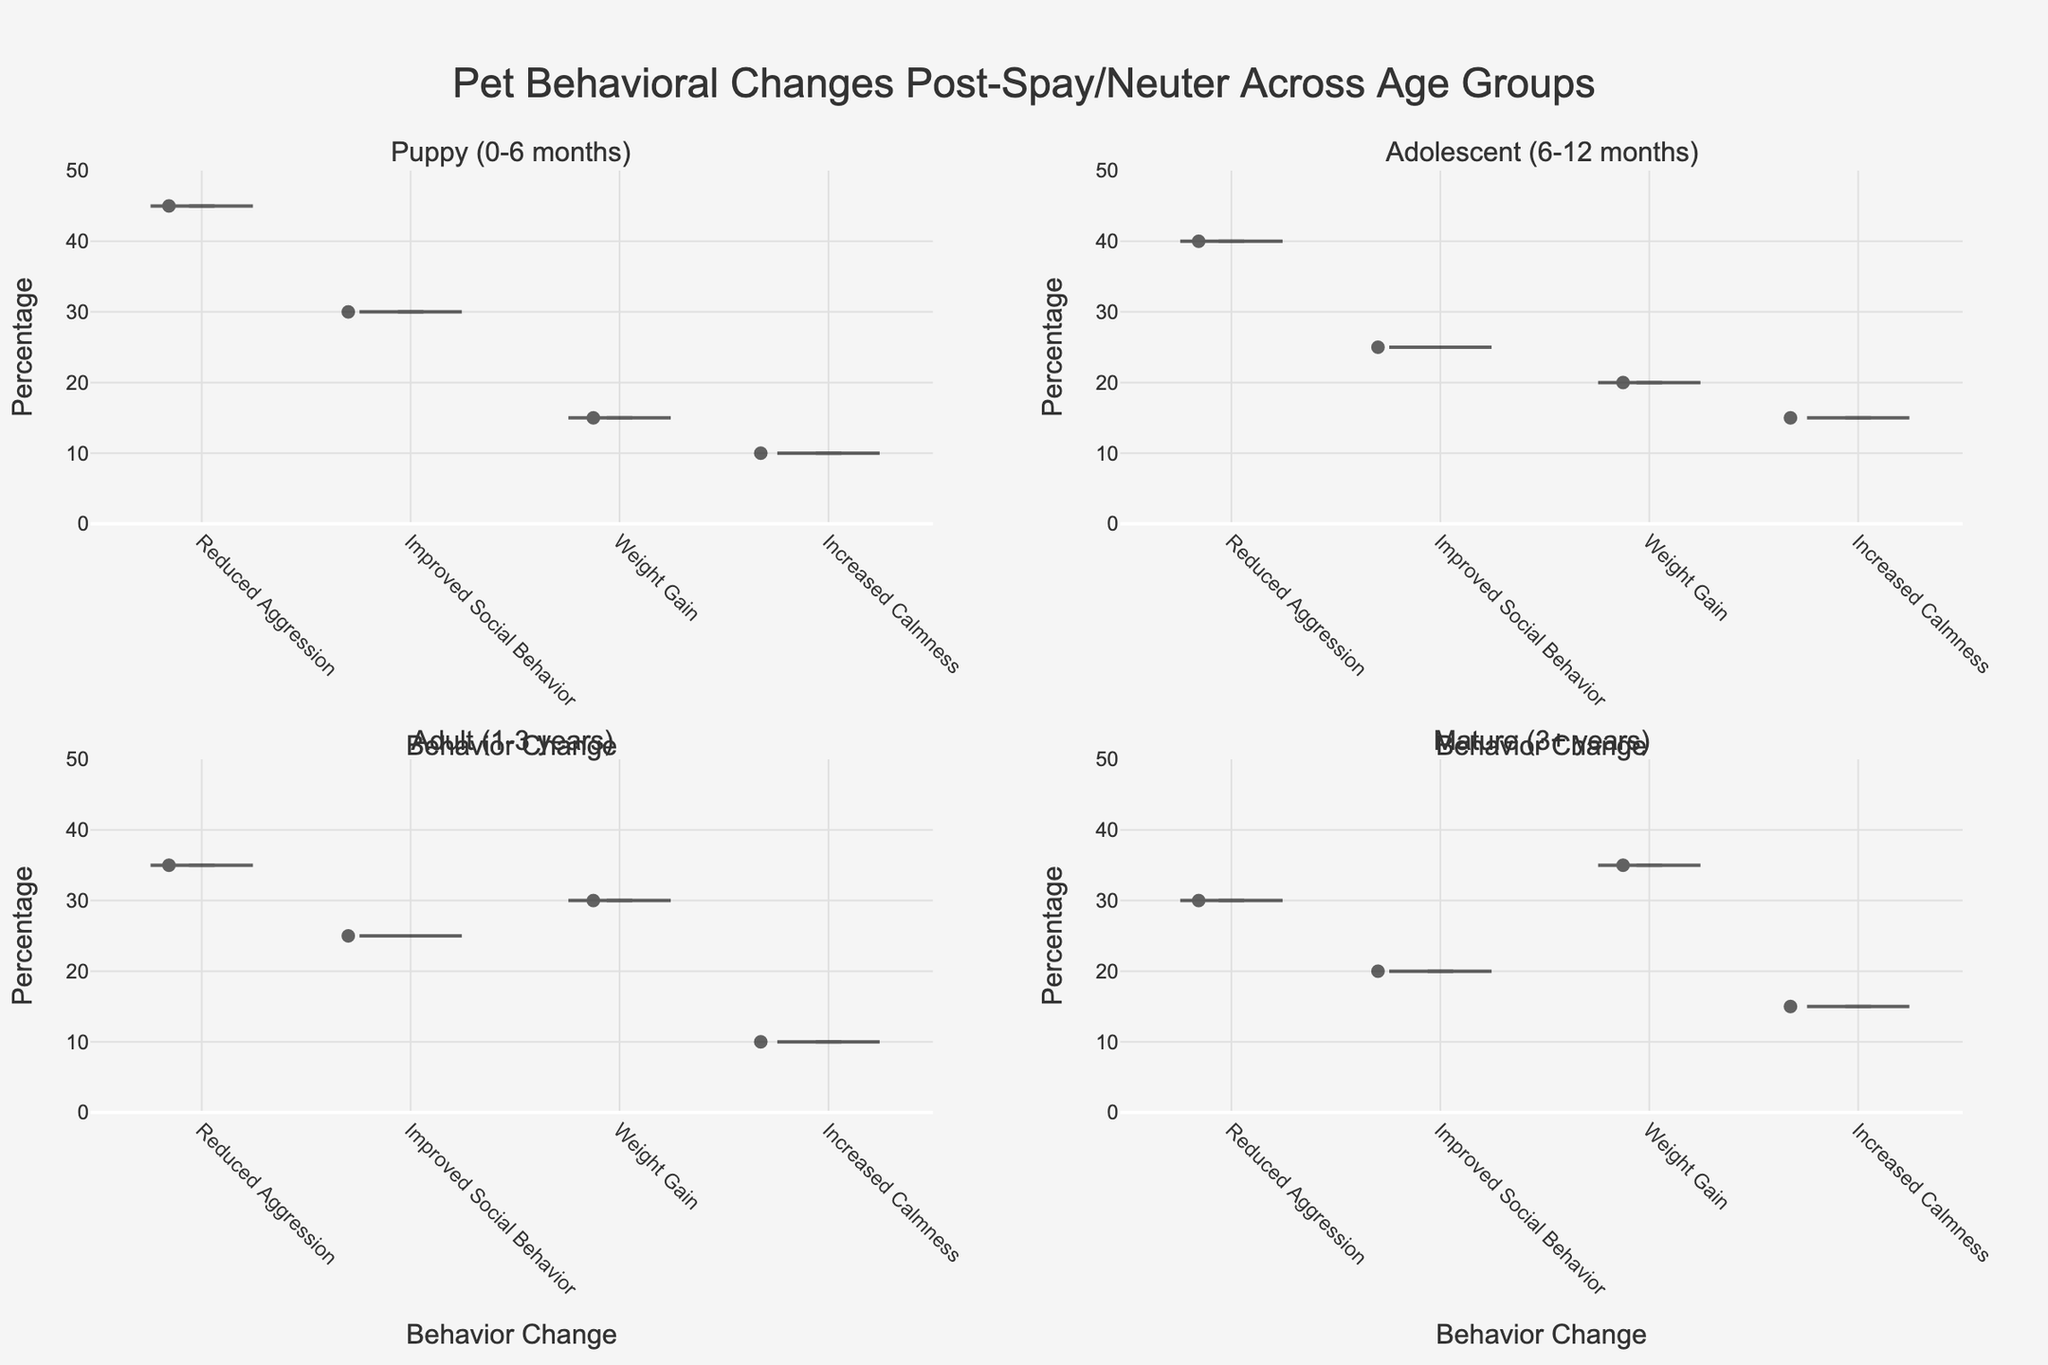What is the title of the figure? The title is located at the top of the figure and provides a summary of what the figure represents.
Answer: Pet Behavioral Changes Post-Spay/Neuter Across Age Groups Which age group has the highest percentage for "Weight Gain"? Look at the percentage values for "Weight Gain" across all age groups and identify the highest one.
Answer: Mature (3+ years) What is the percentage of "Reduced Aggression" for puppies? Find the corresponding data point for "Reduced Aggression" in the Puppy (0-6 months) age group.
Answer: 45 How many behavioral changes are shown in each subplot? Count the distinct behavioral changes (x-axis categories) appearing in any given subplot for one age group.
Answer: Four Which age group shows the highest total percentage for "Improved Social Behavior"? Compare the percentages of "Improved Social Behavior" across all age groups and identify the highest one.
Answer: Puppy (0-6 months) How much higher is the percentage of "Improved Social Behavior" in puppies compared to adults? Subtract the "Improved Social Behavior" percentage of adults (25) from that of puppies (30).
Answer: 5 Is "Increased Calmness" always less than "Reduced Aggression" across all age groups? Compare the percentages of "Increased Calmness" and "Reduced Aggression" for each age group to see if the former is consistently lower.
Answer: Yes Which behavioral change shows the least variance across different age groups? Compare the spread of percentage points for each behavioral change across all age groups to identify the one with the least variance.
Answer: Increased Calmness What visual element helps identify individual data points within the violin plots? Consider the design elements that indicate individual measurements within each violin chart.
Answer: Black dots Among all age groups, where does the percentage of "Weight Gain" increase the most? Identify the age group with the largest increase in the percentage for "Weight Gain" compared to the previous age group.
Answer: Adult (1-3 years) to Mature (3+ years) 